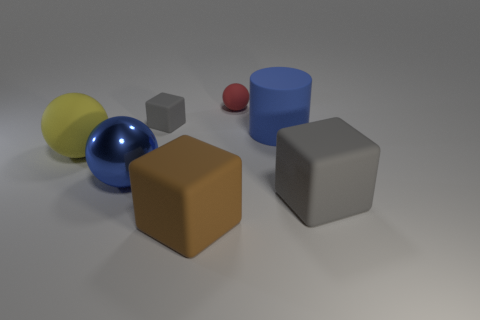Subtract all yellow blocks. Subtract all blue cylinders. How many blocks are left? 3 Add 3 tiny red matte cubes. How many objects exist? 10 Subtract all cubes. How many objects are left? 4 Subtract 1 yellow spheres. How many objects are left? 6 Subtract all gray metal things. Subtract all blue cylinders. How many objects are left? 6 Add 5 gray things. How many gray things are left? 7 Add 1 small blue metallic cylinders. How many small blue metallic cylinders exist? 1 